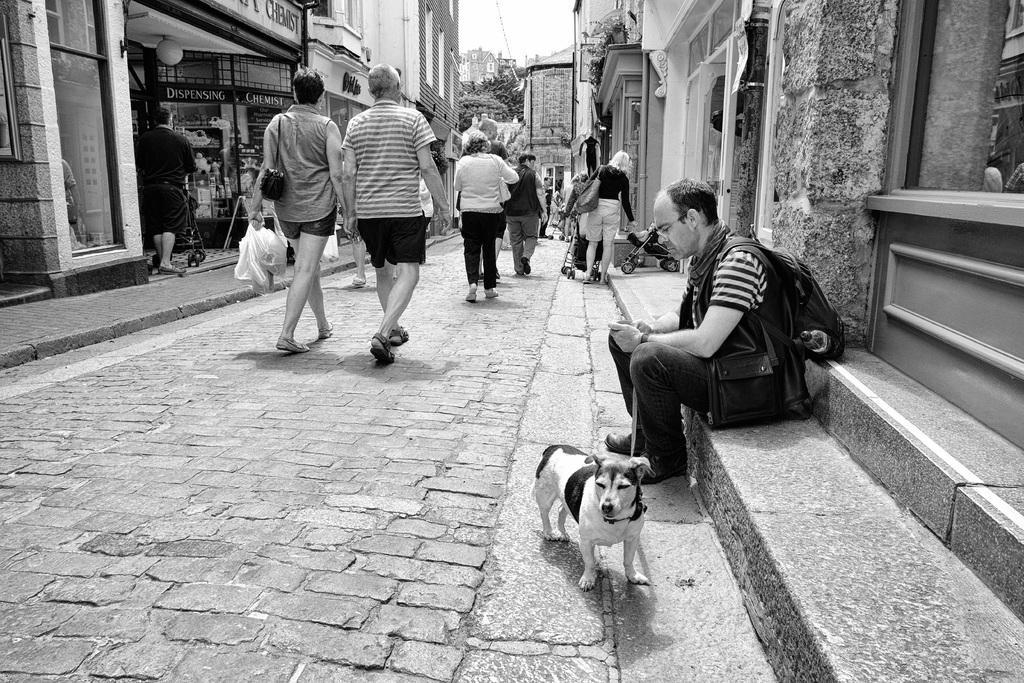Please provide a concise description of this image. In the image the right side the man is sitting in front of him there is a dog. And in the center there are group of people were walking on the road. And the center and holding the right side of the woman she is holding plastic covers and holding the bag the color of black. In front of this people there are three more people walking on the road and the right side of the people there is a lady she is standing she is holding a bag she is looking at cycle. And coming to the top of the left here the man was standing and coming to the background there was a building and some trees. 